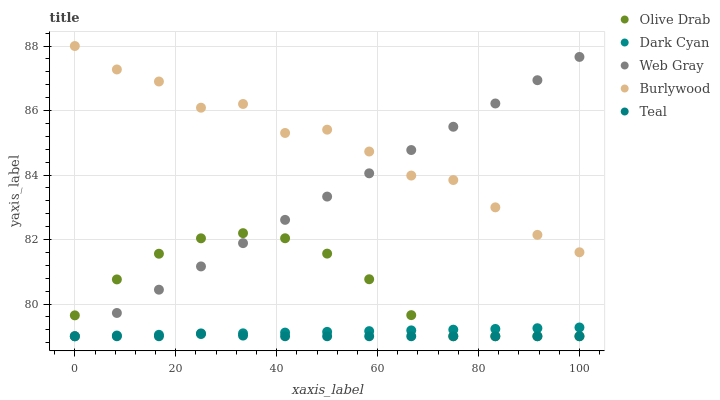Does Teal have the minimum area under the curve?
Answer yes or no. Yes. Does Burlywood have the maximum area under the curve?
Answer yes or no. Yes. Does Web Gray have the minimum area under the curve?
Answer yes or no. No. Does Web Gray have the maximum area under the curve?
Answer yes or no. No. Is Web Gray the smoothest?
Answer yes or no. Yes. Is Burlywood the roughest?
Answer yes or no. Yes. Is Burlywood the smoothest?
Answer yes or no. No. Is Web Gray the roughest?
Answer yes or no. No. Does Dark Cyan have the lowest value?
Answer yes or no. Yes. Does Burlywood have the lowest value?
Answer yes or no. No. Does Burlywood have the highest value?
Answer yes or no. Yes. Does Web Gray have the highest value?
Answer yes or no. No. Is Dark Cyan less than Burlywood?
Answer yes or no. Yes. Is Burlywood greater than Olive Drab?
Answer yes or no. Yes. Does Web Gray intersect Burlywood?
Answer yes or no. Yes. Is Web Gray less than Burlywood?
Answer yes or no. No. Is Web Gray greater than Burlywood?
Answer yes or no. No. Does Dark Cyan intersect Burlywood?
Answer yes or no. No. 